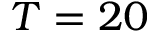Convert formula to latex. <formula><loc_0><loc_0><loc_500><loc_500>T = 2 0</formula> 